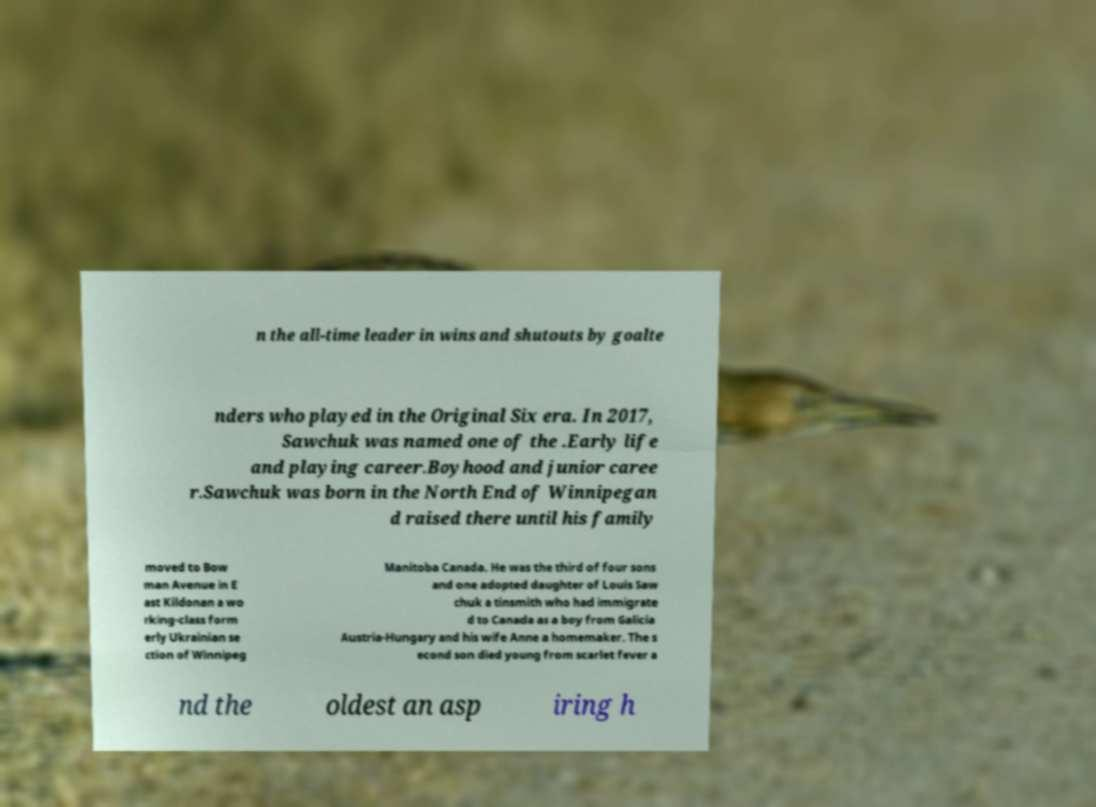I need the written content from this picture converted into text. Can you do that? n the all-time leader in wins and shutouts by goalte nders who played in the Original Six era. In 2017, Sawchuk was named one of the .Early life and playing career.Boyhood and junior caree r.Sawchuk was born in the North End of Winnipegan d raised there until his family moved to Bow man Avenue in E ast Kildonan a wo rking-class form erly Ukrainian se ction of Winnipeg Manitoba Canada. He was the third of four sons and one adopted daughter of Louis Saw chuk a tinsmith who had immigrate d to Canada as a boy from Galicia Austria-Hungary and his wife Anne a homemaker. The s econd son died young from scarlet fever a nd the oldest an asp iring h 